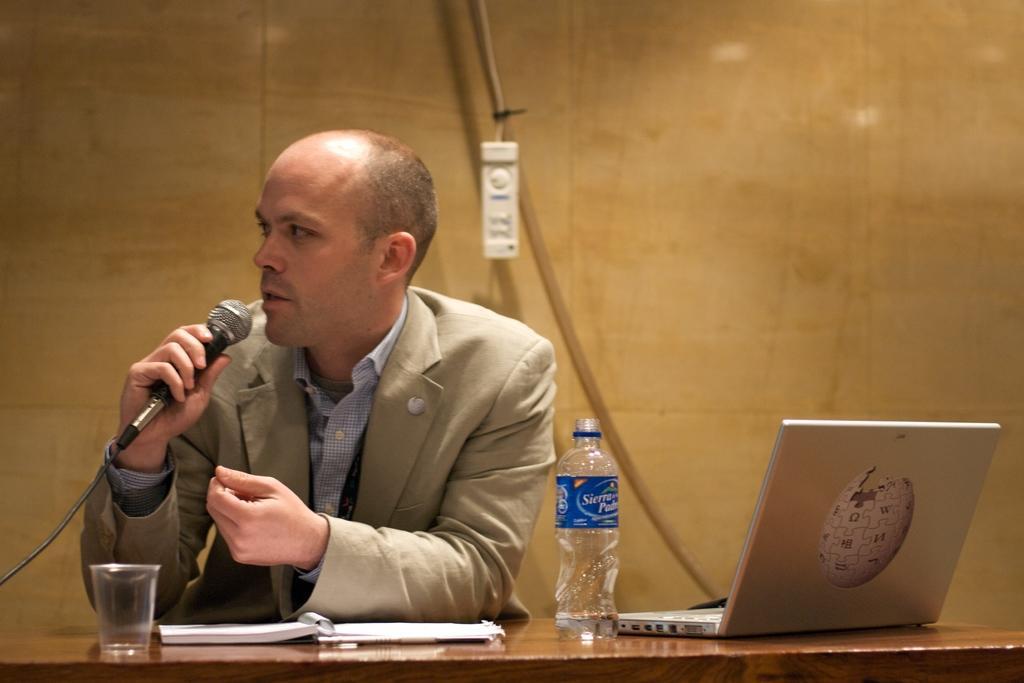Could you give a brief overview of what you see in this image? In this picture there is a man who is wearing blazer and shirt. He is holding a mic. He is sitting near to the table. On the table we can see water bottle, water glass, book and laptop. On the back we can see wire and some white object near to the wall. 